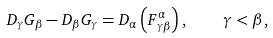Convert formula to latex. <formula><loc_0><loc_0><loc_500><loc_500>D _ { \gamma } G _ { \beta } - D _ { \beta } G _ { \gamma } = D _ { \alpha } \left ( F ^ { \alpha } _ { \gamma \beta } \right ) , \quad \gamma < \beta ,</formula> 